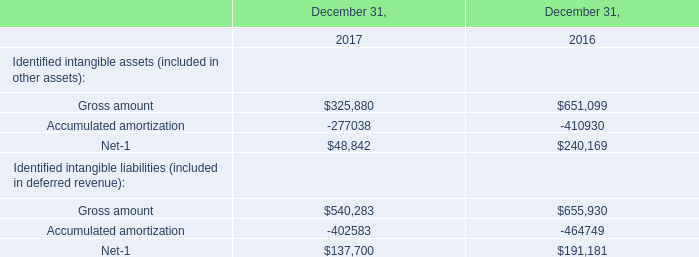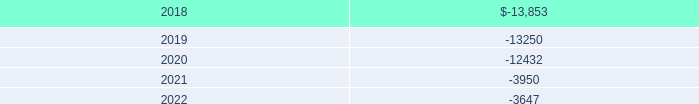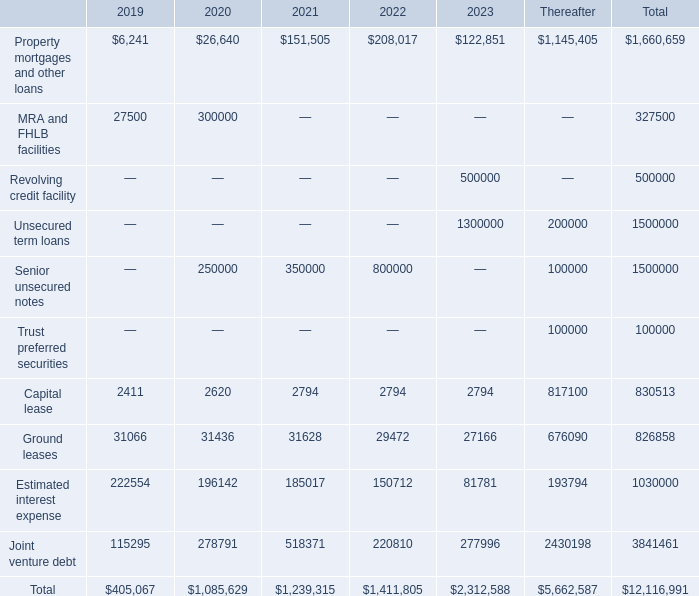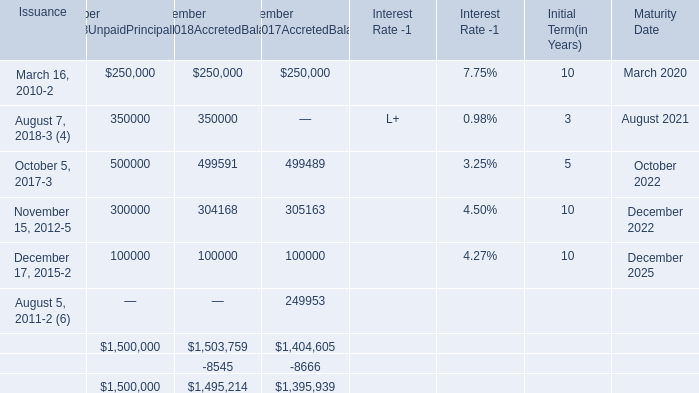What is the average amount of Ground leases of Thereafter, and August 7, 2018 of Maturity Date is ? 
Computations: ((676090.0 + 2021.0) / 2)
Answer: 339055.5. 